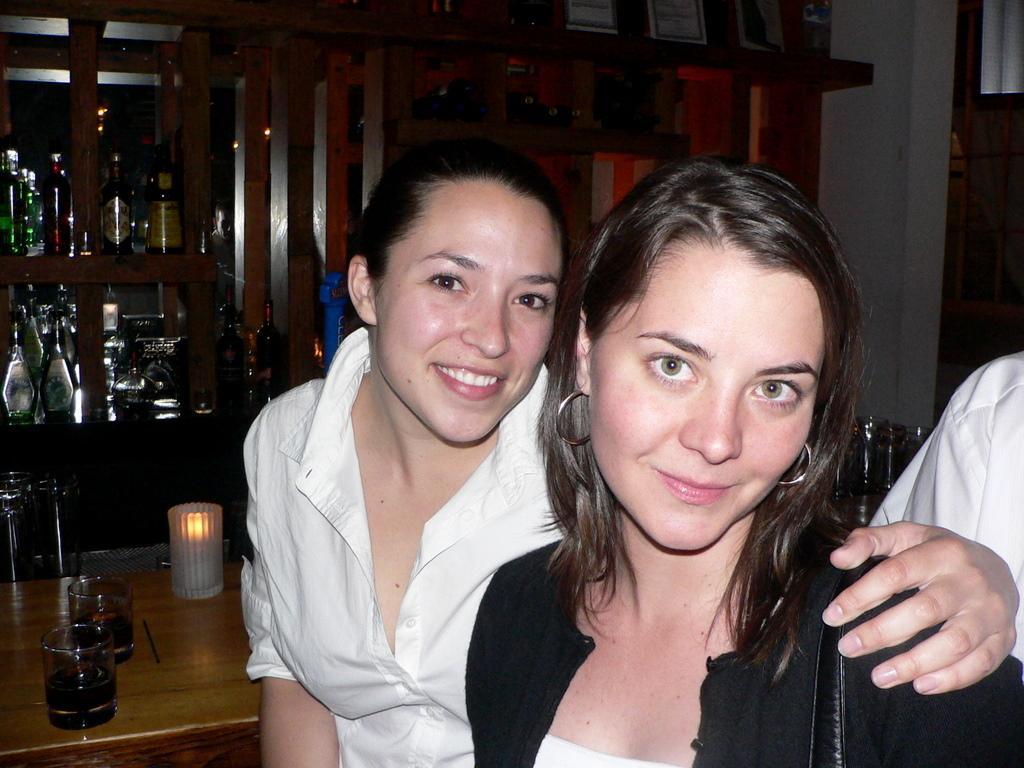Describe this image in one or two sentences. In the foreground I can see three persons and a table on which glasses and a candle is there. In the background I can see a wall, shelves in which bottles are there. This image is taken in a room. 